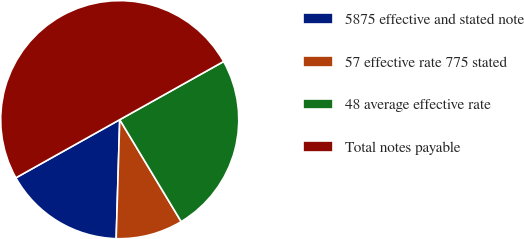<chart> <loc_0><loc_0><loc_500><loc_500><pie_chart><fcel>5875 effective and stated note<fcel>57 effective rate 775 stated<fcel>48 average effective rate<fcel>Total notes payable<nl><fcel>16.4%<fcel>9.11%<fcel>24.49%<fcel>50.0%<nl></chart> 